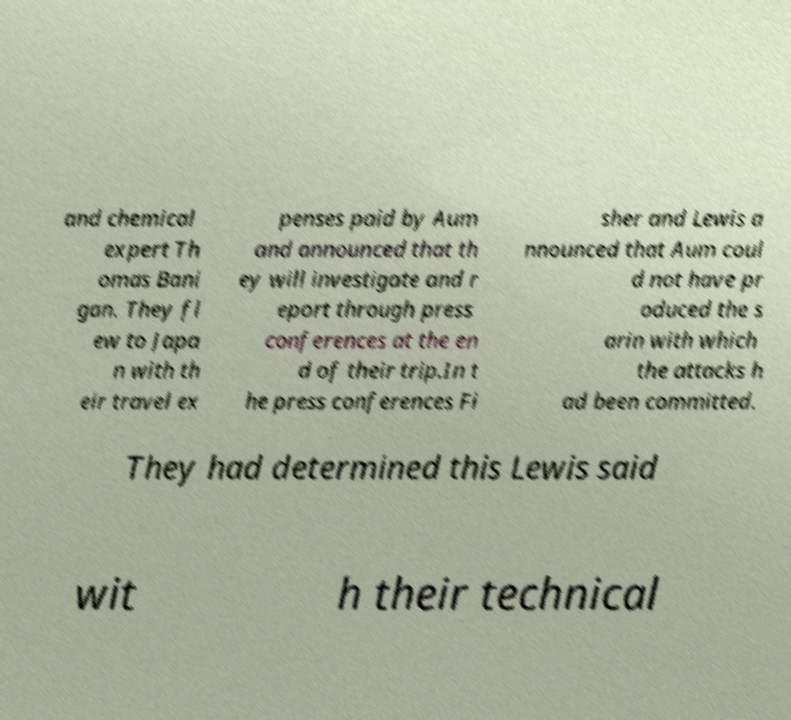Please identify and transcribe the text found in this image. and chemical expert Th omas Bani gan. They fl ew to Japa n with th eir travel ex penses paid by Aum and announced that th ey will investigate and r eport through press conferences at the en d of their trip.In t he press conferences Fi sher and Lewis a nnounced that Aum coul d not have pr oduced the s arin with which the attacks h ad been committed. They had determined this Lewis said wit h their technical 